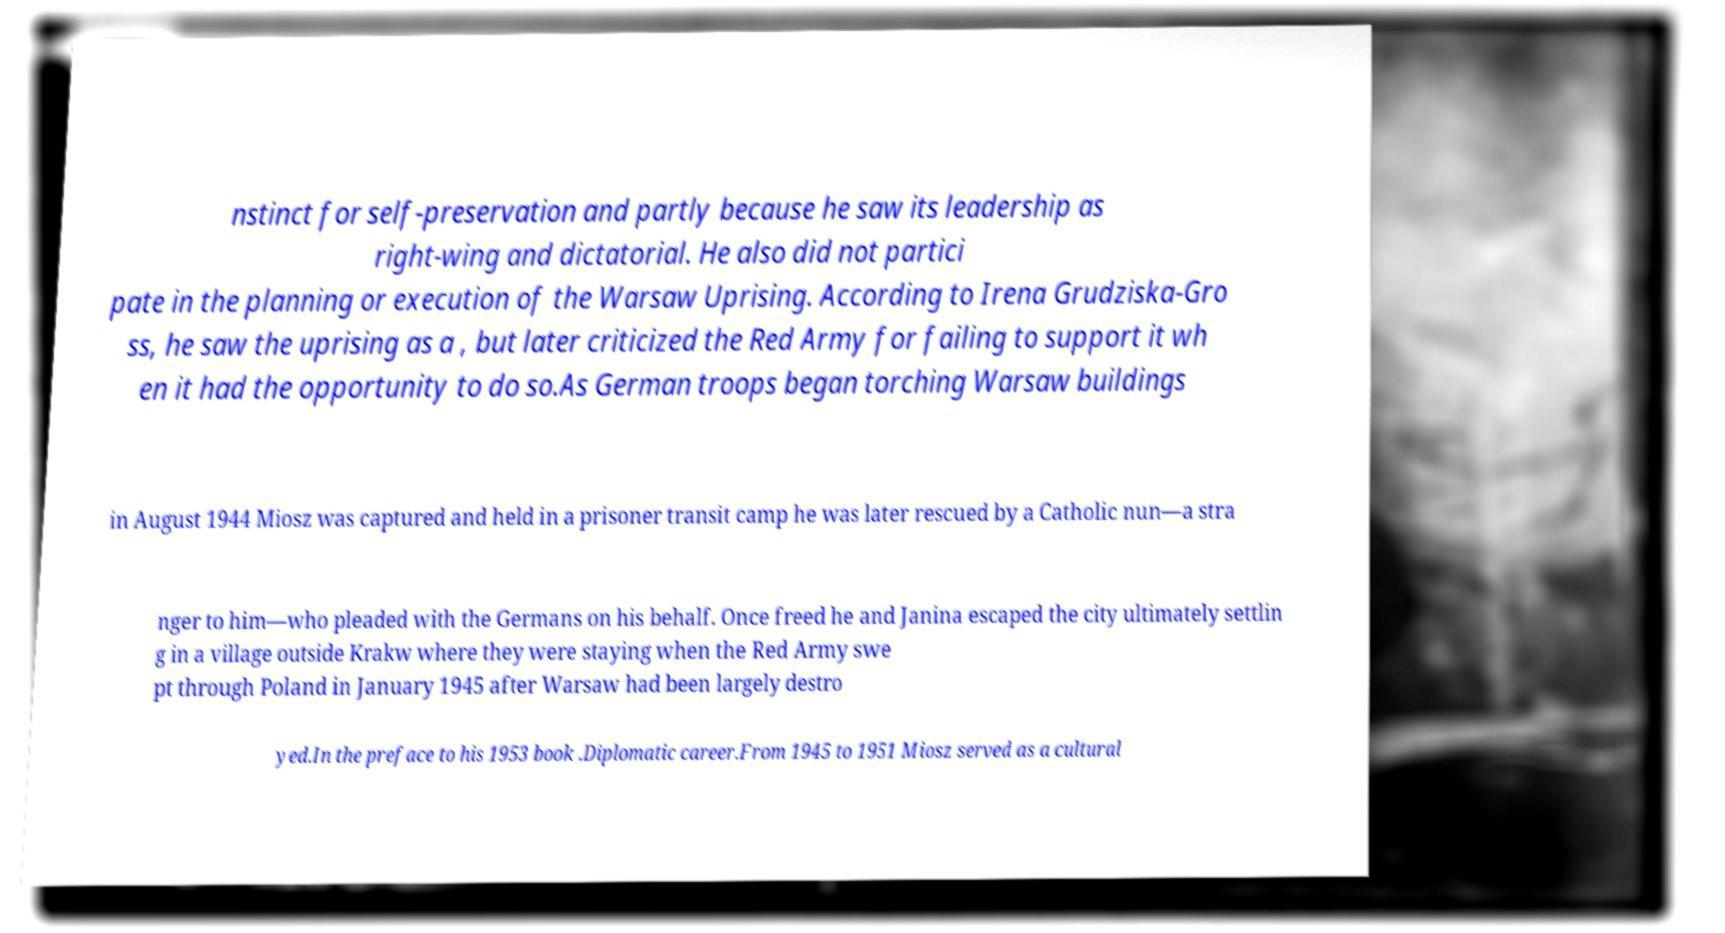Could you extract and type out the text from this image? nstinct for self-preservation and partly because he saw its leadership as right-wing and dictatorial. He also did not partici pate in the planning or execution of the Warsaw Uprising. According to Irena Grudziska-Gro ss, he saw the uprising as a , but later criticized the Red Army for failing to support it wh en it had the opportunity to do so.As German troops began torching Warsaw buildings in August 1944 Miosz was captured and held in a prisoner transit camp he was later rescued by a Catholic nun—a stra nger to him—who pleaded with the Germans on his behalf. Once freed he and Janina escaped the city ultimately settlin g in a village outside Krakw where they were staying when the Red Army swe pt through Poland in January 1945 after Warsaw had been largely destro yed.In the preface to his 1953 book .Diplomatic career.From 1945 to 1951 Miosz served as a cultural 